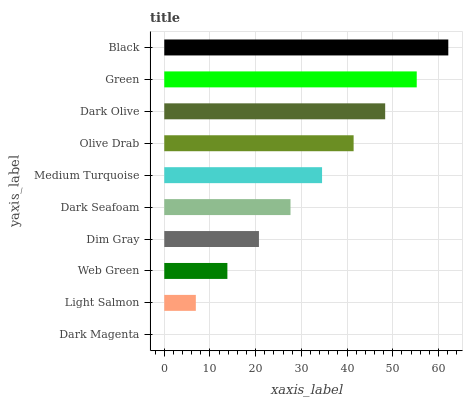Is Dark Magenta the minimum?
Answer yes or no. Yes. Is Black the maximum?
Answer yes or no. Yes. Is Light Salmon the minimum?
Answer yes or no. No. Is Light Salmon the maximum?
Answer yes or no. No. Is Light Salmon greater than Dark Magenta?
Answer yes or no. Yes. Is Dark Magenta less than Light Salmon?
Answer yes or no. Yes. Is Dark Magenta greater than Light Salmon?
Answer yes or no. No. Is Light Salmon less than Dark Magenta?
Answer yes or no. No. Is Medium Turquoise the high median?
Answer yes or no. Yes. Is Dark Seafoam the low median?
Answer yes or no. Yes. Is Dark Olive the high median?
Answer yes or no. No. Is Green the low median?
Answer yes or no. No. 